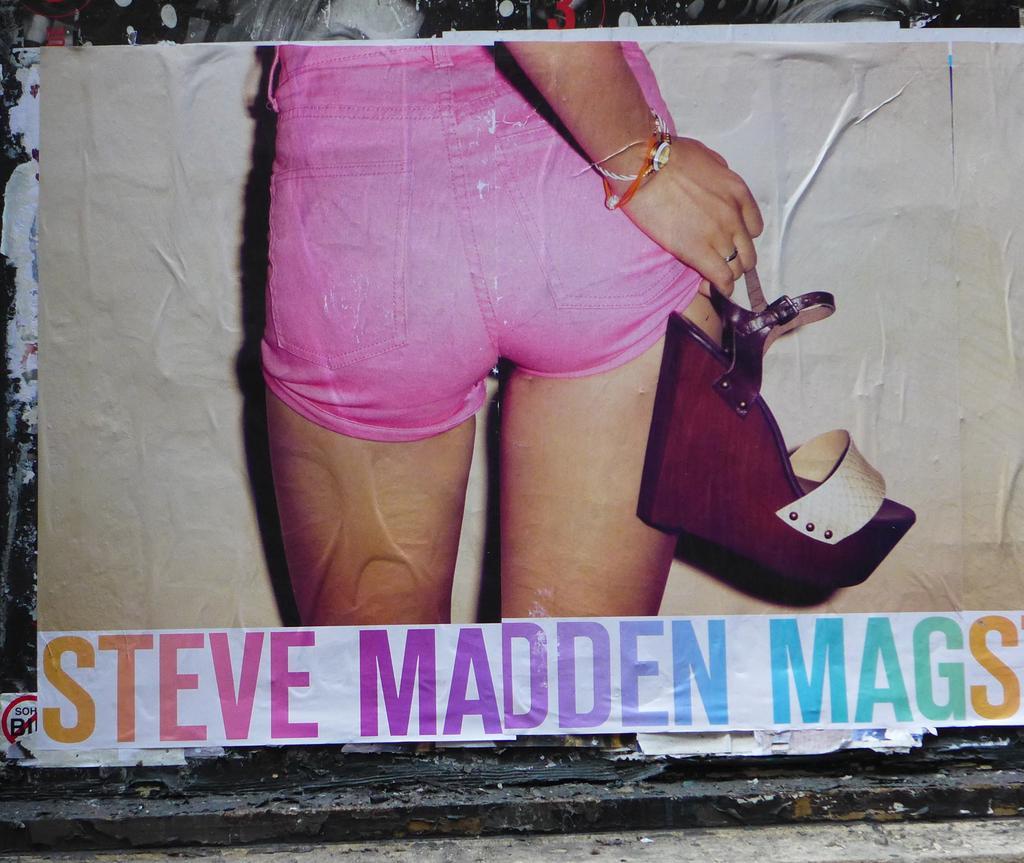Describe this image in one or two sentences. In this image I can see a poster of a person holding a footwear and some matter is written at the bottom. 